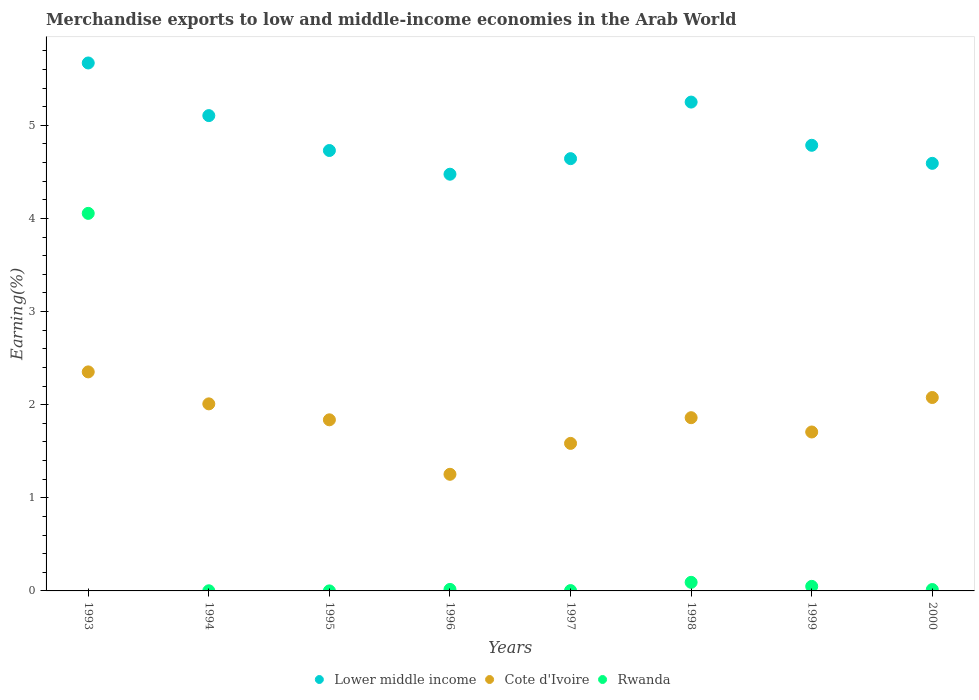How many different coloured dotlines are there?
Your answer should be compact. 3. Is the number of dotlines equal to the number of legend labels?
Offer a terse response. Yes. What is the percentage of amount earned from merchandise exports in Cote d'Ivoire in 1993?
Provide a short and direct response. 2.35. Across all years, what is the maximum percentage of amount earned from merchandise exports in Rwanda?
Your answer should be compact. 4.05. Across all years, what is the minimum percentage of amount earned from merchandise exports in Lower middle income?
Provide a succinct answer. 4.48. In which year was the percentage of amount earned from merchandise exports in Rwanda minimum?
Your answer should be very brief. 1995. What is the total percentage of amount earned from merchandise exports in Cote d'Ivoire in the graph?
Keep it short and to the point. 14.68. What is the difference between the percentage of amount earned from merchandise exports in Rwanda in 1997 and that in 1999?
Offer a terse response. -0.05. What is the difference between the percentage of amount earned from merchandise exports in Rwanda in 2000 and the percentage of amount earned from merchandise exports in Cote d'Ivoire in 1996?
Keep it short and to the point. -1.24. What is the average percentage of amount earned from merchandise exports in Rwanda per year?
Provide a short and direct response. 0.53. In the year 1998, what is the difference between the percentage of amount earned from merchandise exports in Lower middle income and percentage of amount earned from merchandise exports in Rwanda?
Make the answer very short. 5.16. What is the ratio of the percentage of amount earned from merchandise exports in Cote d'Ivoire in 1996 to that in 1997?
Ensure brevity in your answer.  0.79. Is the percentage of amount earned from merchandise exports in Rwanda in 1995 less than that in 1999?
Your response must be concise. Yes. Is the difference between the percentage of amount earned from merchandise exports in Lower middle income in 1993 and 1995 greater than the difference between the percentage of amount earned from merchandise exports in Rwanda in 1993 and 1995?
Ensure brevity in your answer.  No. What is the difference between the highest and the second highest percentage of amount earned from merchandise exports in Lower middle income?
Your answer should be very brief. 0.42. What is the difference between the highest and the lowest percentage of amount earned from merchandise exports in Rwanda?
Provide a short and direct response. 4.05. Is the sum of the percentage of amount earned from merchandise exports in Lower middle income in 1995 and 1998 greater than the maximum percentage of amount earned from merchandise exports in Cote d'Ivoire across all years?
Provide a short and direct response. Yes. Is the percentage of amount earned from merchandise exports in Lower middle income strictly less than the percentage of amount earned from merchandise exports in Cote d'Ivoire over the years?
Offer a very short reply. No. How many dotlines are there?
Your response must be concise. 3. How many years are there in the graph?
Ensure brevity in your answer.  8. Does the graph contain any zero values?
Your answer should be compact. No. How many legend labels are there?
Your response must be concise. 3. How are the legend labels stacked?
Make the answer very short. Horizontal. What is the title of the graph?
Your answer should be compact. Merchandise exports to low and middle-income economies in the Arab World. Does "Singapore" appear as one of the legend labels in the graph?
Ensure brevity in your answer.  No. What is the label or title of the Y-axis?
Your answer should be compact. Earning(%). What is the Earning(%) in Lower middle income in 1993?
Your answer should be very brief. 5.67. What is the Earning(%) in Cote d'Ivoire in 1993?
Make the answer very short. 2.35. What is the Earning(%) in Rwanda in 1993?
Offer a very short reply. 4.05. What is the Earning(%) of Lower middle income in 1994?
Keep it short and to the point. 5.1. What is the Earning(%) of Cote d'Ivoire in 1994?
Give a very brief answer. 2.01. What is the Earning(%) in Rwanda in 1994?
Your answer should be compact. 0. What is the Earning(%) in Lower middle income in 1995?
Give a very brief answer. 4.73. What is the Earning(%) of Cote d'Ivoire in 1995?
Ensure brevity in your answer.  1.84. What is the Earning(%) in Rwanda in 1995?
Ensure brevity in your answer.  0. What is the Earning(%) in Lower middle income in 1996?
Your answer should be very brief. 4.48. What is the Earning(%) of Cote d'Ivoire in 1996?
Keep it short and to the point. 1.25. What is the Earning(%) in Rwanda in 1996?
Offer a terse response. 0.02. What is the Earning(%) in Lower middle income in 1997?
Keep it short and to the point. 4.64. What is the Earning(%) in Cote d'Ivoire in 1997?
Keep it short and to the point. 1.58. What is the Earning(%) in Rwanda in 1997?
Your answer should be very brief. 0. What is the Earning(%) of Lower middle income in 1998?
Make the answer very short. 5.25. What is the Earning(%) of Cote d'Ivoire in 1998?
Give a very brief answer. 1.86. What is the Earning(%) of Rwanda in 1998?
Your answer should be very brief. 0.09. What is the Earning(%) of Lower middle income in 1999?
Your answer should be very brief. 4.79. What is the Earning(%) in Cote d'Ivoire in 1999?
Your answer should be compact. 1.71. What is the Earning(%) in Rwanda in 1999?
Your answer should be very brief. 0.05. What is the Earning(%) of Lower middle income in 2000?
Provide a succinct answer. 4.59. What is the Earning(%) in Cote d'Ivoire in 2000?
Your response must be concise. 2.08. What is the Earning(%) in Rwanda in 2000?
Offer a terse response. 0.01. Across all years, what is the maximum Earning(%) in Lower middle income?
Provide a short and direct response. 5.67. Across all years, what is the maximum Earning(%) of Cote d'Ivoire?
Your response must be concise. 2.35. Across all years, what is the maximum Earning(%) in Rwanda?
Offer a very short reply. 4.05. Across all years, what is the minimum Earning(%) of Lower middle income?
Provide a succinct answer. 4.48. Across all years, what is the minimum Earning(%) in Cote d'Ivoire?
Offer a terse response. 1.25. Across all years, what is the minimum Earning(%) of Rwanda?
Make the answer very short. 0. What is the total Earning(%) of Lower middle income in the graph?
Your answer should be very brief. 39.25. What is the total Earning(%) in Cote d'Ivoire in the graph?
Your answer should be very brief. 14.68. What is the total Earning(%) in Rwanda in the graph?
Offer a very short reply. 4.23. What is the difference between the Earning(%) in Lower middle income in 1993 and that in 1994?
Ensure brevity in your answer.  0.57. What is the difference between the Earning(%) in Cote d'Ivoire in 1993 and that in 1994?
Make the answer very short. 0.34. What is the difference between the Earning(%) of Rwanda in 1993 and that in 1994?
Provide a succinct answer. 4.05. What is the difference between the Earning(%) of Cote d'Ivoire in 1993 and that in 1995?
Make the answer very short. 0.51. What is the difference between the Earning(%) in Rwanda in 1993 and that in 1995?
Your response must be concise. 4.05. What is the difference between the Earning(%) of Lower middle income in 1993 and that in 1996?
Provide a succinct answer. 1.19. What is the difference between the Earning(%) in Cote d'Ivoire in 1993 and that in 1996?
Keep it short and to the point. 1.1. What is the difference between the Earning(%) of Rwanda in 1993 and that in 1996?
Offer a very short reply. 4.04. What is the difference between the Earning(%) of Lower middle income in 1993 and that in 1997?
Offer a very short reply. 1.03. What is the difference between the Earning(%) in Cote d'Ivoire in 1993 and that in 1997?
Make the answer very short. 0.77. What is the difference between the Earning(%) in Rwanda in 1993 and that in 1997?
Ensure brevity in your answer.  4.05. What is the difference between the Earning(%) of Lower middle income in 1993 and that in 1998?
Provide a short and direct response. 0.42. What is the difference between the Earning(%) in Cote d'Ivoire in 1993 and that in 1998?
Keep it short and to the point. 0.49. What is the difference between the Earning(%) in Rwanda in 1993 and that in 1998?
Make the answer very short. 3.96. What is the difference between the Earning(%) of Lower middle income in 1993 and that in 1999?
Make the answer very short. 0.88. What is the difference between the Earning(%) of Cote d'Ivoire in 1993 and that in 1999?
Offer a terse response. 0.65. What is the difference between the Earning(%) of Rwanda in 1993 and that in 1999?
Your answer should be compact. 4.01. What is the difference between the Earning(%) of Lower middle income in 1993 and that in 2000?
Offer a very short reply. 1.08. What is the difference between the Earning(%) in Cote d'Ivoire in 1993 and that in 2000?
Provide a succinct answer. 0.28. What is the difference between the Earning(%) of Rwanda in 1993 and that in 2000?
Offer a very short reply. 4.04. What is the difference between the Earning(%) of Lower middle income in 1994 and that in 1995?
Ensure brevity in your answer.  0.37. What is the difference between the Earning(%) in Cote d'Ivoire in 1994 and that in 1995?
Give a very brief answer. 0.17. What is the difference between the Earning(%) of Rwanda in 1994 and that in 1995?
Ensure brevity in your answer.  0. What is the difference between the Earning(%) of Lower middle income in 1994 and that in 1996?
Keep it short and to the point. 0.63. What is the difference between the Earning(%) in Cote d'Ivoire in 1994 and that in 1996?
Give a very brief answer. 0.76. What is the difference between the Earning(%) in Rwanda in 1994 and that in 1996?
Provide a succinct answer. -0.01. What is the difference between the Earning(%) in Lower middle income in 1994 and that in 1997?
Keep it short and to the point. 0.46. What is the difference between the Earning(%) in Cote d'Ivoire in 1994 and that in 1997?
Your response must be concise. 0.42. What is the difference between the Earning(%) of Rwanda in 1994 and that in 1997?
Ensure brevity in your answer.  -0. What is the difference between the Earning(%) of Lower middle income in 1994 and that in 1998?
Your answer should be compact. -0.15. What is the difference between the Earning(%) of Cote d'Ivoire in 1994 and that in 1998?
Provide a short and direct response. 0.15. What is the difference between the Earning(%) in Rwanda in 1994 and that in 1998?
Offer a terse response. -0.09. What is the difference between the Earning(%) of Lower middle income in 1994 and that in 1999?
Your answer should be very brief. 0.32. What is the difference between the Earning(%) of Cote d'Ivoire in 1994 and that in 1999?
Make the answer very short. 0.3. What is the difference between the Earning(%) in Rwanda in 1994 and that in 1999?
Your answer should be very brief. -0.05. What is the difference between the Earning(%) of Lower middle income in 1994 and that in 2000?
Provide a succinct answer. 0.51. What is the difference between the Earning(%) of Cote d'Ivoire in 1994 and that in 2000?
Your answer should be compact. -0.07. What is the difference between the Earning(%) in Rwanda in 1994 and that in 2000?
Ensure brevity in your answer.  -0.01. What is the difference between the Earning(%) of Lower middle income in 1995 and that in 1996?
Your answer should be compact. 0.25. What is the difference between the Earning(%) of Cote d'Ivoire in 1995 and that in 1996?
Make the answer very short. 0.59. What is the difference between the Earning(%) in Rwanda in 1995 and that in 1996?
Your answer should be very brief. -0.02. What is the difference between the Earning(%) in Lower middle income in 1995 and that in 1997?
Offer a very short reply. 0.09. What is the difference between the Earning(%) in Cote d'Ivoire in 1995 and that in 1997?
Provide a short and direct response. 0.25. What is the difference between the Earning(%) in Rwanda in 1995 and that in 1997?
Give a very brief answer. -0. What is the difference between the Earning(%) in Lower middle income in 1995 and that in 1998?
Your answer should be compact. -0.52. What is the difference between the Earning(%) in Cote d'Ivoire in 1995 and that in 1998?
Offer a very short reply. -0.02. What is the difference between the Earning(%) of Rwanda in 1995 and that in 1998?
Your answer should be compact. -0.09. What is the difference between the Earning(%) of Lower middle income in 1995 and that in 1999?
Offer a terse response. -0.06. What is the difference between the Earning(%) of Cote d'Ivoire in 1995 and that in 1999?
Give a very brief answer. 0.13. What is the difference between the Earning(%) in Rwanda in 1995 and that in 1999?
Keep it short and to the point. -0.05. What is the difference between the Earning(%) in Lower middle income in 1995 and that in 2000?
Ensure brevity in your answer.  0.14. What is the difference between the Earning(%) of Cote d'Ivoire in 1995 and that in 2000?
Provide a short and direct response. -0.24. What is the difference between the Earning(%) in Rwanda in 1995 and that in 2000?
Make the answer very short. -0.01. What is the difference between the Earning(%) in Lower middle income in 1996 and that in 1997?
Make the answer very short. -0.17. What is the difference between the Earning(%) in Cote d'Ivoire in 1996 and that in 1997?
Offer a terse response. -0.33. What is the difference between the Earning(%) of Rwanda in 1996 and that in 1997?
Offer a terse response. 0.01. What is the difference between the Earning(%) in Lower middle income in 1996 and that in 1998?
Keep it short and to the point. -0.77. What is the difference between the Earning(%) in Cote d'Ivoire in 1996 and that in 1998?
Make the answer very short. -0.61. What is the difference between the Earning(%) in Rwanda in 1996 and that in 1998?
Make the answer very short. -0.08. What is the difference between the Earning(%) in Lower middle income in 1996 and that in 1999?
Offer a terse response. -0.31. What is the difference between the Earning(%) in Cote d'Ivoire in 1996 and that in 1999?
Offer a very short reply. -0.45. What is the difference between the Earning(%) of Rwanda in 1996 and that in 1999?
Provide a short and direct response. -0.03. What is the difference between the Earning(%) of Lower middle income in 1996 and that in 2000?
Provide a succinct answer. -0.12. What is the difference between the Earning(%) of Cote d'Ivoire in 1996 and that in 2000?
Provide a short and direct response. -0.82. What is the difference between the Earning(%) of Rwanda in 1996 and that in 2000?
Provide a short and direct response. 0. What is the difference between the Earning(%) of Lower middle income in 1997 and that in 1998?
Give a very brief answer. -0.61. What is the difference between the Earning(%) of Cote d'Ivoire in 1997 and that in 1998?
Keep it short and to the point. -0.28. What is the difference between the Earning(%) of Rwanda in 1997 and that in 1998?
Make the answer very short. -0.09. What is the difference between the Earning(%) in Lower middle income in 1997 and that in 1999?
Provide a succinct answer. -0.14. What is the difference between the Earning(%) of Cote d'Ivoire in 1997 and that in 1999?
Your answer should be compact. -0.12. What is the difference between the Earning(%) in Rwanda in 1997 and that in 1999?
Provide a succinct answer. -0.05. What is the difference between the Earning(%) of Lower middle income in 1997 and that in 2000?
Offer a very short reply. 0.05. What is the difference between the Earning(%) in Cote d'Ivoire in 1997 and that in 2000?
Provide a short and direct response. -0.49. What is the difference between the Earning(%) of Rwanda in 1997 and that in 2000?
Give a very brief answer. -0.01. What is the difference between the Earning(%) of Lower middle income in 1998 and that in 1999?
Your response must be concise. 0.46. What is the difference between the Earning(%) in Cote d'Ivoire in 1998 and that in 1999?
Provide a short and direct response. 0.15. What is the difference between the Earning(%) of Rwanda in 1998 and that in 1999?
Provide a succinct answer. 0.04. What is the difference between the Earning(%) in Lower middle income in 1998 and that in 2000?
Offer a very short reply. 0.66. What is the difference between the Earning(%) in Cote d'Ivoire in 1998 and that in 2000?
Provide a succinct answer. -0.22. What is the difference between the Earning(%) in Rwanda in 1998 and that in 2000?
Keep it short and to the point. 0.08. What is the difference between the Earning(%) in Lower middle income in 1999 and that in 2000?
Provide a succinct answer. 0.19. What is the difference between the Earning(%) of Cote d'Ivoire in 1999 and that in 2000?
Offer a terse response. -0.37. What is the difference between the Earning(%) of Rwanda in 1999 and that in 2000?
Offer a terse response. 0.03. What is the difference between the Earning(%) in Lower middle income in 1993 and the Earning(%) in Cote d'Ivoire in 1994?
Keep it short and to the point. 3.66. What is the difference between the Earning(%) of Lower middle income in 1993 and the Earning(%) of Rwanda in 1994?
Keep it short and to the point. 5.67. What is the difference between the Earning(%) of Cote d'Ivoire in 1993 and the Earning(%) of Rwanda in 1994?
Provide a short and direct response. 2.35. What is the difference between the Earning(%) of Lower middle income in 1993 and the Earning(%) of Cote d'Ivoire in 1995?
Your answer should be compact. 3.83. What is the difference between the Earning(%) of Lower middle income in 1993 and the Earning(%) of Rwanda in 1995?
Provide a succinct answer. 5.67. What is the difference between the Earning(%) of Cote d'Ivoire in 1993 and the Earning(%) of Rwanda in 1995?
Your response must be concise. 2.35. What is the difference between the Earning(%) of Lower middle income in 1993 and the Earning(%) of Cote d'Ivoire in 1996?
Keep it short and to the point. 4.42. What is the difference between the Earning(%) in Lower middle income in 1993 and the Earning(%) in Rwanda in 1996?
Provide a succinct answer. 5.65. What is the difference between the Earning(%) of Cote d'Ivoire in 1993 and the Earning(%) of Rwanda in 1996?
Your answer should be compact. 2.34. What is the difference between the Earning(%) of Lower middle income in 1993 and the Earning(%) of Cote d'Ivoire in 1997?
Make the answer very short. 4.09. What is the difference between the Earning(%) in Lower middle income in 1993 and the Earning(%) in Rwanda in 1997?
Offer a very short reply. 5.67. What is the difference between the Earning(%) in Cote d'Ivoire in 1993 and the Earning(%) in Rwanda in 1997?
Provide a succinct answer. 2.35. What is the difference between the Earning(%) in Lower middle income in 1993 and the Earning(%) in Cote d'Ivoire in 1998?
Your answer should be very brief. 3.81. What is the difference between the Earning(%) in Lower middle income in 1993 and the Earning(%) in Rwanda in 1998?
Make the answer very short. 5.58. What is the difference between the Earning(%) in Cote d'Ivoire in 1993 and the Earning(%) in Rwanda in 1998?
Your answer should be very brief. 2.26. What is the difference between the Earning(%) in Lower middle income in 1993 and the Earning(%) in Cote d'Ivoire in 1999?
Your answer should be compact. 3.96. What is the difference between the Earning(%) of Lower middle income in 1993 and the Earning(%) of Rwanda in 1999?
Offer a terse response. 5.62. What is the difference between the Earning(%) in Cote d'Ivoire in 1993 and the Earning(%) in Rwanda in 1999?
Give a very brief answer. 2.3. What is the difference between the Earning(%) of Lower middle income in 1993 and the Earning(%) of Cote d'Ivoire in 2000?
Your answer should be compact. 3.59. What is the difference between the Earning(%) in Lower middle income in 1993 and the Earning(%) in Rwanda in 2000?
Your answer should be compact. 5.66. What is the difference between the Earning(%) in Cote d'Ivoire in 1993 and the Earning(%) in Rwanda in 2000?
Keep it short and to the point. 2.34. What is the difference between the Earning(%) in Lower middle income in 1994 and the Earning(%) in Cote d'Ivoire in 1995?
Provide a short and direct response. 3.27. What is the difference between the Earning(%) in Lower middle income in 1994 and the Earning(%) in Rwanda in 1995?
Provide a succinct answer. 5.1. What is the difference between the Earning(%) in Cote d'Ivoire in 1994 and the Earning(%) in Rwanda in 1995?
Provide a short and direct response. 2.01. What is the difference between the Earning(%) of Lower middle income in 1994 and the Earning(%) of Cote d'Ivoire in 1996?
Keep it short and to the point. 3.85. What is the difference between the Earning(%) of Lower middle income in 1994 and the Earning(%) of Rwanda in 1996?
Provide a succinct answer. 5.09. What is the difference between the Earning(%) in Cote d'Ivoire in 1994 and the Earning(%) in Rwanda in 1996?
Give a very brief answer. 1.99. What is the difference between the Earning(%) in Lower middle income in 1994 and the Earning(%) in Cote d'Ivoire in 1997?
Offer a terse response. 3.52. What is the difference between the Earning(%) of Lower middle income in 1994 and the Earning(%) of Rwanda in 1997?
Provide a short and direct response. 5.1. What is the difference between the Earning(%) in Cote d'Ivoire in 1994 and the Earning(%) in Rwanda in 1997?
Give a very brief answer. 2.01. What is the difference between the Earning(%) in Lower middle income in 1994 and the Earning(%) in Cote d'Ivoire in 1998?
Your response must be concise. 3.24. What is the difference between the Earning(%) in Lower middle income in 1994 and the Earning(%) in Rwanda in 1998?
Make the answer very short. 5.01. What is the difference between the Earning(%) of Cote d'Ivoire in 1994 and the Earning(%) of Rwanda in 1998?
Your response must be concise. 1.92. What is the difference between the Earning(%) in Lower middle income in 1994 and the Earning(%) in Cote d'Ivoire in 1999?
Give a very brief answer. 3.4. What is the difference between the Earning(%) of Lower middle income in 1994 and the Earning(%) of Rwanda in 1999?
Ensure brevity in your answer.  5.06. What is the difference between the Earning(%) of Cote d'Ivoire in 1994 and the Earning(%) of Rwanda in 1999?
Your answer should be compact. 1.96. What is the difference between the Earning(%) of Lower middle income in 1994 and the Earning(%) of Cote d'Ivoire in 2000?
Your answer should be compact. 3.03. What is the difference between the Earning(%) in Lower middle income in 1994 and the Earning(%) in Rwanda in 2000?
Give a very brief answer. 5.09. What is the difference between the Earning(%) of Cote d'Ivoire in 1994 and the Earning(%) of Rwanda in 2000?
Provide a short and direct response. 1.99. What is the difference between the Earning(%) in Lower middle income in 1995 and the Earning(%) in Cote d'Ivoire in 1996?
Give a very brief answer. 3.48. What is the difference between the Earning(%) in Lower middle income in 1995 and the Earning(%) in Rwanda in 1996?
Offer a very short reply. 4.71. What is the difference between the Earning(%) of Cote d'Ivoire in 1995 and the Earning(%) of Rwanda in 1996?
Provide a short and direct response. 1.82. What is the difference between the Earning(%) of Lower middle income in 1995 and the Earning(%) of Cote d'Ivoire in 1997?
Provide a short and direct response. 3.15. What is the difference between the Earning(%) in Lower middle income in 1995 and the Earning(%) in Rwanda in 1997?
Provide a succinct answer. 4.73. What is the difference between the Earning(%) of Cote d'Ivoire in 1995 and the Earning(%) of Rwanda in 1997?
Offer a terse response. 1.83. What is the difference between the Earning(%) in Lower middle income in 1995 and the Earning(%) in Cote d'Ivoire in 1998?
Provide a succinct answer. 2.87. What is the difference between the Earning(%) in Lower middle income in 1995 and the Earning(%) in Rwanda in 1998?
Offer a very short reply. 4.64. What is the difference between the Earning(%) of Cote d'Ivoire in 1995 and the Earning(%) of Rwanda in 1998?
Keep it short and to the point. 1.75. What is the difference between the Earning(%) of Lower middle income in 1995 and the Earning(%) of Cote d'Ivoire in 1999?
Provide a short and direct response. 3.02. What is the difference between the Earning(%) of Lower middle income in 1995 and the Earning(%) of Rwanda in 1999?
Make the answer very short. 4.68. What is the difference between the Earning(%) of Cote d'Ivoire in 1995 and the Earning(%) of Rwanda in 1999?
Make the answer very short. 1.79. What is the difference between the Earning(%) of Lower middle income in 1995 and the Earning(%) of Cote d'Ivoire in 2000?
Offer a terse response. 2.65. What is the difference between the Earning(%) of Lower middle income in 1995 and the Earning(%) of Rwanda in 2000?
Offer a terse response. 4.71. What is the difference between the Earning(%) of Cote d'Ivoire in 1995 and the Earning(%) of Rwanda in 2000?
Ensure brevity in your answer.  1.82. What is the difference between the Earning(%) of Lower middle income in 1996 and the Earning(%) of Cote d'Ivoire in 1997?
Your answer should be very brief. 2.89. What is the difference between the Earning(%) of Lower middle income in 1996 and the Earning(%) of Rwanda in 1997?
Ensure brevity in your answer.  4.47. What is the difference between the Earning(%) of Cote d'Ivoire in 1996 and the Earning(%) of Rwanda in 1997?
Provide a short and direct response. 1.25. What is the difference between the Earning(%) of Lower middle income in 1996 and the Earning(%) of Cote d'Ivoire in 1998?
Keep it short and to the point. 2.61. What is the difference between the Earning(%) in Lower middle income in 1996 and the Earning(%) in Rwanda in 1998?
Provide a short and direct response. 4.38. What is the difference between the Earning(%) of Cote d'Ivoire in 1996 and the Earning(%) of Rwanda in 1998?
Your answer should be compact. 1.16. What is the difference between the Earning(%) in Lower middle income in 1996 and the Earning(%) in Cote d'Ivoire in 1999?
Provide a succinct answer. 2.77. What is the difference between the Earning(%) of Lower middle income in 1996 and the Earning(%) of Rwanda in 1999?
Make the answer very short. 4.43. What is the difference between the Earning(%) of Cote d'Ivoire in 1996 and the Earning(%) of Rwanda in 1999?
Offer a terse response. 1.2. What is the difference between the Earning(%) in Lower middle income in 1996 and the Earning(%) in Cote d'Ivoire in 2000?
Provide a short and direct response. 2.4. What is the difference between the Earning(%) in Lower middle income in 1996 and the Earning(%) in Rwanda in 2000?
Provide a succinct answer. 4.46. What is the difference between the Earning(%) in Cote d'Ivoire in 1996 and the Earning(%) in Rwanda in 2000?
Your answer should be very brief. 1.24. What is the difference between the Earning(%) in Lower middle income in 1997 and the Earning(%) in Cote d'Ivoire in 1998?
Make the answer very short. 2.78. What is the difference between the Earning(%) of Lower middle income in 1997 and the Earning(%) of Rwanda in 1998?
Provide a short and direct response. 4.55. What is the difference between the Earning(%) of Cote d'Ivoire in 1997 and the Earning(%) of Rwanda in 1998?
Ensure brevity in your answer.  1.49. What is the difference between the Earning(%) of Lower middle income in 1997 and the Earning(%) of Cote d'Ivoire in 1999?
Offer a terse response. 2.94. What is the difference between the Earning(%) in Lower middle income in 1997 and the Earning(%) in Rwanda in 1999?
Your response must be concise. 4.59. What is the difference between the Earning(%) in Cote d'Ivoire in 1997 and the Earning(%) in Rwanda in 1999?
Keep it short and to the point. 1.54. What is the difference between the Earning(%) of Lower middle income in 1997 and the Earning(%) of Cote d'Ivoire in 2000?
Provide a succinct answer. 2.57. What is the difference between the Earning(%) in Lower middle income in 1997 and the Earning(%) in Rwanda in 2000?
Your answer should be compact. 4.63. What is the difference between the Earning(%) of Cote d'Ivoire in 1997 and the Earning(%) of Rwanda in 2000?
Keep it short and to the point. 1.57. What is the difference between the Earning(%) in Lower middle income in 1998 and the Earning(%) in Cote d'Ivoire in 1999?
Your answer should be compact. 3.54. What is the difference between the Earning(%) of Lower middle income in 1998 and the Earning(%) of Rwanda in 1999?
Your answer should be compact. 5.2. What is the difference between the Earning(%) in Cote d'Ivoire in 1998 and the Earning(%) in Rwanda in 1999?
Ensure brevity in your answer.  1.81. What is the difference between the Earning(%) of Lower middle income in 1998 and the Earning(%) of Cote d'Ivoire in 2000?
Provide a short and direct response. 3.17. What is the difference between the Earning(%) of Lower middle income in 1998 and the Earning(%) of Rwanda in 2000?
Provide a succinct answer. 5.24. What is the difference between the Earning(%) in Cote d'Ivoire in 1998 and the Earning(%) in Rwanda in 2000?
Ensure brevity in your answer.  1.85. What is the difference between the Earning(%) of Lower middle income in 1999 and the Earning(%) of Cote d'Ivoire in 2000?
Your answer should be very brief. 2.71. What is the difference between the Earning(%) of Lower middle income in 1999 and the Earning(%) of Rwanda in 2000?
Your answer should be compact. 4.77. What is the difference between the Earning(%) in Cote d'Ivoire in 1999 and the Earning(%) in Rwanda in 2000?
Your answer should be compact. 1.69. What is the average Earning(%) in Lower middle income per year?
Ensure brevity in your answer.  4.91. What is the average Earning(%) of Cote d'Ivoire per year?
Keep it short and to the point. 1.83. What is the average Earning(%) in Rwanda per year?
Keep it short and to the point. 0.53. In the year 1993, what is the difference between the Earning(%) in Lower middle income and Earning(%) in Cote d'Ivoire?
Your response must be concise. 3.32. In the year 1993, what is the difference between the Earning(%) of Lower middle income and Earning(%) of Rwanda?
Offer a very short reply. 1.62. In the year 1993, what is the difference between the Earning(%) in Cote d'Ivoire and Earning(%) in Rwanda?
Provide a short and direct response. -1.7. In the year 1994, what is the difference between the Earning(%) of Lower middle income and Earning(%) of Cote d'Ivoire?
Provide a succinct answer. 3.1. In the year 1994, what is the difference between the Earning(%) of Lower middle income and Earning(%) of Rwanda?
Offer a terse response. 5.1. In the year 1994, what is the difference between the Earning(%) of Cote d'Ivoire and Earning(%) of Rwanda?
Keep it short and to the point. 2.01. In the year 1995, what is the difference between the Earning(%) of Lower middle income and Earning(%) of Cote d'Ivoire?
Keep it short and to the point. 2.89. In the year 1995, what is the difference between the Earning(%) of Lower middle income and Earning(%) of Rwanda?
Give a very brief answer. 4.73. In the year 1995, what is the difference between the Earning(%) of Cote d'Ivoire and Earning(%) of Rwanda?
Provide a succinct answer. 1.84. In the year 1996, what is the difference between the Earning(%) in Lower middle income and Earning(%) in Cote d'Ivoire?
Keep it short and to the point. 3.22. In the year 1996, what is the difference between the Earning(%) of Lower middle income and Earning(%) of Rwanda?
Offer a terse response. 4.46. In the year 1996, what is the difference between the Earning(%) in Cote d'Ivoire and Earning(%) in Rwanda?
Your answer should be compact. 1.24. In the year 1997, what is the difference between the Earning(%) in Lower middle income and Earning(%) in Cote d'Ivoire?
Make the answer very short. 3.06. In the year 1997, what is the difference between the Earning(%) in Lower middle income and Earning(%) in Rwanda?
Your response must be concise. 4.64. In the year 1997, what is the difference between the Earning(%) of Cote d'Ivoire and Earning(%) of Rwanda?
Offer a terse response. 1.58. In the year 1998, what is the difference between the Earning(%) of Lower middle income and Earning(%) of Cote d'Ivoire?
Offer a terse response. 3.39. In the year 1998, what is the difference between the Earning(%) of Lower middle income and Earning(%) of Rwanda?
Provide a succinct answer. 5.16. In the year 1998, what is the difference between the Earning(%) in Cote d'Ivoire and Earning(%) in Rwanda?
Your answer should be very brief. 1.77. In the year 1999, what is the difference between the Earning(%) in Lower middle income and Earning(%) in Cote d'Ivoire?
Your answer should be compact. 3.08. In the year 1999, what is the difference between the Earning(%) in Lower middle income and Earning(%) in Rwanda?
Make the answer very short. 4.74. In the year 1999, what is the difference between the Earning(%) of Cote d'Ivoire and Earning(%) of Rwanda?
Offer a very short reply. 1.66. In the year 2000, what is the difference between the Earning(%) in Lower middle income and Earning(%) in Cote d'Ivoire?
Give a very brief answer. 2.51. In the year 2000, what is the difference between the Earning(%) in Lower middle income and Earning(%) in Rwanda?
Your response must be concise. 4.58. In the year 2000, what is the difference between the Earning(%) in Cote d'Ivoire and Earning(%) in Rwanda?
Ensure brevity in your answer.  2.06. What is the ratio of the Earning(%) in Lower middle income in 1993 to that in 1994?
Make the answer very short. 1.11. What is the ratio of the Earning(%) of Cote d'Ivoire in 1993 to that in 1994?
Keep it short and to the point. 1.17. What is the ratio of the Earning(%) of Rwanda in 1993 to that in 1994?
Offer a very short reply. 2596.26. What is the ratio of the Earning(%) of Lower middle income in 1993 to that in 1995?
Give a very brief answer. 1.2. What is the ratio of the Earning(%) in Cote d'Ivoire in 1993 to that in 1995?
Give a very brief answer. 1.28. What is the ratio of the Earning(%) of Rwanda in 1993 to that in 1995?
Provide a succinct answer. 1.35e+04. What is the ratio of the Earning(%) of Lower middle income in 1993 to that in 1996?
Your answer should be very brief. 1.27. What is the ratio of the Earning(%) in Cote d'Ivoire in 1993 to that in 1996?
Your answer should be compact. 1.88. What is the ratio of the Earning(%) of Rwanda in 1993 to that in 1996?
Provide a succinct answer. 248.6. What is the ratio of the Earning(%) in Lower middle income in 1993 to that in 1997?
Offer a terse response. 1.22. What is the ratio of the Earning(%) in Cote d'Ivoire in 1993 to that in 1997?
Your answer should be very brief. 1.48. What is the ratio of the Earning(%) in Rwanda in 1993 to that in 1997?
Offer a terse response. 1114.63. What is the ratio of the Earning(%) of Cote d'Ivoire in 1993 to that in 1998?
Your response must be concise. 1.26. What is the ratio of the Earning(%) of Rwanda in 1993 to that in 1998?
Offer a terse response. 43.98. What is the ratio of the Earning(%) in Lower middle income in 1993 to that in 1999?
Give a very brief answer. 1.18. What is the ratio of the Earning(%) of Cote d'Ivoire in 1993 to that in 1999?
Make the answer very short. 1.38. What is the ratio of the Earning(%) of Rwanda in 1993 to that in 1999?
Provide a short and direct response. 82.92. What is the ratio of the Earning(%) in Lower middle income in 1993 to that in 2000?
Keep it short and to the point. 1.23. What is the ratio of the Earning(%) in Cote d'Ivoire in 1993 to that in 2000?
Your answer should be very brief. 1.13. What is the ratio of the Earning(%) of Rwanda in 1993 to that in 2000?
Offer a very short reply. 273.45. What is the ratio of the Earning(%) of Lower middle income in 1994 to that in 1995?
Offer a very short reply. 1.08. What is the ratio of the Earning(%) of Cote d'Ivoire in 1994 to that in 1995?
Offer a very short reply. 1.09. What is the ratio of the Earning(%) of Rwanda in 1994 to that in 1995?
Provide a succinct answer. 5.21. What is the ratio of the Earning(%) of Lower middle income in 1994 to that in 1996?
Ensure brevity in your answer.  1.14. What is the ratio of the Earning(%) in Cote d'Ivoire in 1994 to that in 1996?
Provide a short and direct response. 1.6. What is the ratio of the Earning(%) in Rwanda in 1994 to that in 1996?
Make the answer very short. 0.1. What is the ratio of the Earning(%) of Lower middle income in 1994 to that in 1997?
Ensure brevity in your answer.  1.1. What is the ratio of the Earning(%) in Cote d'Ivoire in 1994 to that in 1997?
Make the answer very short. 1.27. What is the ratio of the Earning(%) in Rwanda in 1994 to that in 1997?
Ensure brevity in your answer.  0.43. What is the ratio of the Earning(%) of Lower middle income in 1994 to that in 1998?
Make the answer very short. 0.97. What is the ratio of the Earning(%) of Cote d'Ivoire in 1994 to that in 1998?
Your answer should be compact. 1.08. What is the ratio of the Earning(%) in Rwanda in 1994 to that in 1998?
Provide a succinct answer. 0.02. What is the ratio of the Earning(%) of Lower middle income in 1994 to that in 1999?
Make the answer very short. 1.07. What is the ratio of the Earning(%) of Cote d'Ivoire in 1994 to that in 1999?
Offer a very short reply. 1.18. What is the ratio of the Earning(%) of Rwanda in 1994 to that in 1999?
Ensure brevity in your answer.  0.03. What is the ratio of the Earning(%) in Lower middle income in 1994 to that in 2000?
Make the answer very short. 1.11. What is the ratio of the Earning(%) in Cote d'Ivoire in 1994 to that in 2000?
Ensure brevity in your answer.  0.97. What is the ratio of the Earning(%) in Rwanda in 1994 to that in 2000?
Your answer should be very brief. 0.11. What is the ratio of the Earning(%) in Lower middle income in 1995 to that in 1996?
Provide a succinct answer. 1.06. What is the ratio of the Earning(%) of Cote d'Ivoire in 1995 to that in 1996?
Ensure brevity in your answer.  1.47. What is the ratio of the Earning(%) in Rwanda in 1995 to that in 1996?
Your response must be concise. 0.02. What is the ratio of the Earning(%) in Lower middle income in 1995 to that in 1997?
Offer a terse response. 1.02. What is the ratio of the Earning(%) in Cote d'Ivoire in 1995 to that in 1997?
Keep it short and to the point. 1.16. What is the ratio of the Earning(%) of Rwanda in 1995 to that in 1997?
Keep it short and to the point. 0.08. What is the ratio of the Earning(%) of Lower middle income in 1995 to that in 1998?
Your answer should be compact. 0.9. What is the ratio of the Earning(%) of Rwanda in 1995 to that in 1998?
Provide a short and direct response. 0. What is the ratio of the Earning(%) in Lower middle income in 1995 to that in 1999?
Your answer should be very brief. 0.99. What is the ratio of the Earning(%) of Cote d'Ivoire in 1995 to that in 1999?
Make the answer very short. 1.08. What is the ratio of the Earning(%) in Rwanda in 1995 to that in 1999?
Make the answer very short. 0.01. What is the ratio of the Earning(%) of Lower middle income in 1995 to that in 2000?
Provide a succinct answer. 1.03. What is the ratio of the Earning(%) in Cote d'Ivoire in 1995 to that in 2000?
Offer a very short reply. 0.88. What is the ratio of the Earning(%) in Rwanda in 1995 to that in 2000?
Provide a succinct answer. 0.02. What is the ratio of the Earning(%) in Lower middle income in 1996 to that in 1997?
Your answer should be very brief. 0.96. What is the ratio of the Earning(%) in Cote d'Ivoire in 1996 to that in 1997?
Ensure brevity in your answer.  0.79. What is the ratio of the Earning(%) of Rwanda in 1996 to that in 1997?
Provide a short and direct response. 4.48. What is the ratio of the Earning(%) in Lower middle income in 1996 to that in 1998?
Ensure brevity in your answer.  0.85. What is the ratio of the Earning(%) of Cote d'Ivoire in 1996 to that in 1998?
Keep it short and to the point. 0.67. What is the ratio of the Earning(%) in Rwanda in 1996 to that in 1998?
Your answer should be very brief. 0.18. What is the ratio of the Earning(%) in Lower middle income in 1996 to that in 1999?
Your answer should be very brief. 0.94. What is the ratio of the Earning(%) in Cote d'Ivoire in 1996 to that in 1999?
Offer a very short reply. 0.73. What is the ratio of the Earning(%) in Rwanda in 1996 to that in 1999?
Provide a short and direct response. 0.33. What is the ratio of the Earning(%) in Lower middle income in 1996 to that in 2000?
Offer a very short reply. 0.97. What is the ratio of the Earning(%) in Cote d'Ivoire in 1996 to that in 2000?
Provide a short and direct response. 0.6. What is the ratio of the Earning(%) of Rwanda in 1996 to that in 2000?
Your answer should be compact. 1.1. What is the ratio of the Earning(%) in Lower middle income in 1997 to that in 1998?
Offer a terse response. 0.88. What is the ratio of the Earning(%) of Cote d'Ivoire in 1997 to that in 1998?
Offer a terse response. 0.85. What is the ratio of the Earning(%) in Rwanda in 1997 to that in 1998?
Ensure brevity in your answer.  0.04. What is the ratio of the Earning(%) in Cote d'Ivoire in 1997 to that in 1999?
Give a very brief answer. 0.93. What is the ratio of the Earning(%) in Rwanda in 1997 to that in 1999?
Give a very brief answer. 0.07. What is the ratio of the Earning(%) in Cote d'Ivoire in 1997 to that in 2000?
Your answer should be very brief. 0.76. What is the ratio of the Earning(%) in Rwanda in 1997 to that in 2000?
Provide a succinct answer. 0.25. What is the ratio of the Earning(%) in Lower middle income in 1998 to that in 1999?
Your answer should be very brief. 1.1. What is the ratio of the Earning(%) in Cote d'Ivoire in 1998 to that in 1999?
Provide a short and direct response. 1.09. What is the ratio of the Earning(%) in Rwanda in 1998 to that in 1999?
Your answer should be very brief. 1.89. What is the ratio of the Earning(%) of Lower middle income in 1998 to that in 2000?
Make the answer very short. 1.14. What is the ratio of the Earning(%) of Cote d'Ivoire in 1998 to that in 2000?
Keep it short and to the point. 0.9. What is the ratio of the Earning(%) in Rwanda in 1998 to that in 2000?
Your response must be concise. 6.22. What is the ratio of the Earning(%) in Lower middle income in 1999 to that in 2000?
Your response must be concise. 1.04. What is the ratio of the Earning(%) of Cote d'Ivoire in 1999 to that in 2000?
Provide a succinct answer. 0.82. What is the ratio of the Earning(%) of Rwanda in 1999 to that in 2000?
Your answer should be compact. 3.3. What is the difference between the highest and the second highest Earning(%) of Lower middle income?
Provide a succinct answer. 0.42. What is the difference between the highest and the second highest Earning(%) of Cote d'Ivoire?
Provide a short and direct response. 0.28. What is the difference between the highest and the second highest Earning(%) of Rwanda?
Give a very brief answer. 3.96. What is the difference between the highest and the lowest Earning(%) of Lower middle income?
Offer a terse response. 1.19. What is the difference between the highest and the lowest Earning(%) in Cote d'Ivoire?
Give a very brief answer. 1.1. What is the difference between the highest and the lowest Earning(%) of Rwanda?
Your response must be concise. 4.05. 